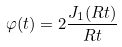<formula> <loc_0><loc_0><loc_500><loc_500>\varphi ( t ) = 2 \frac { J _ { 1 } ( R t ) } { R t }</formula> 